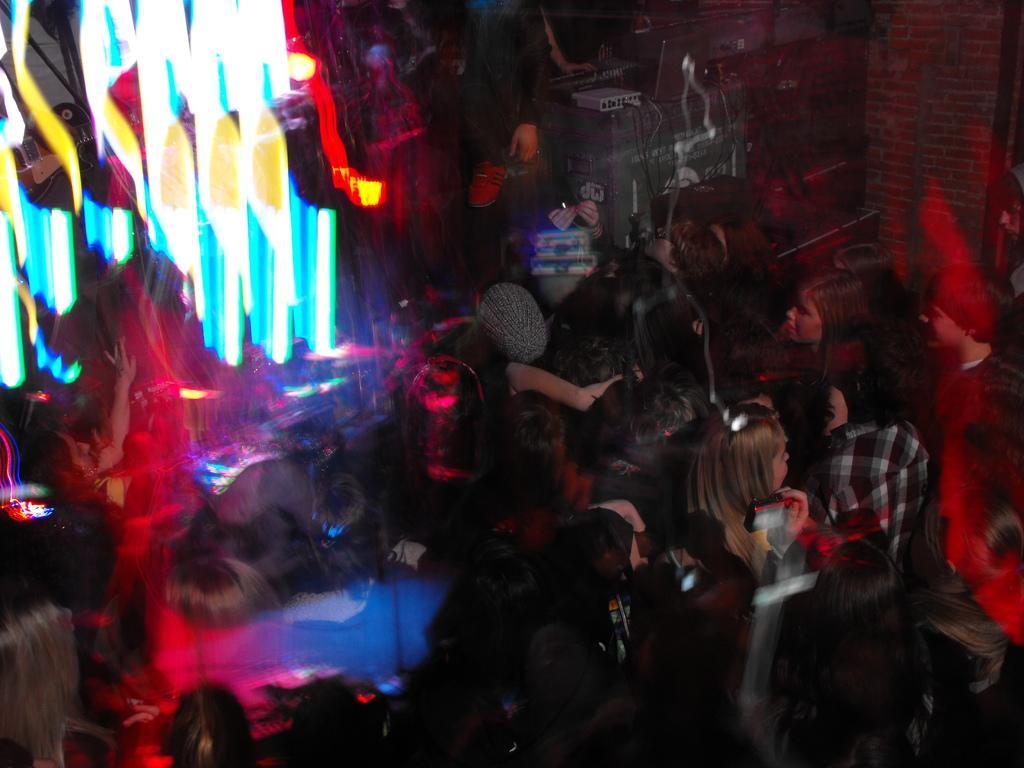Can you describe this image briefly? In this picture there are people in the center of the image and there are colorful lights on the left side of the image and there is an electric box with wires at the top side of the image. 